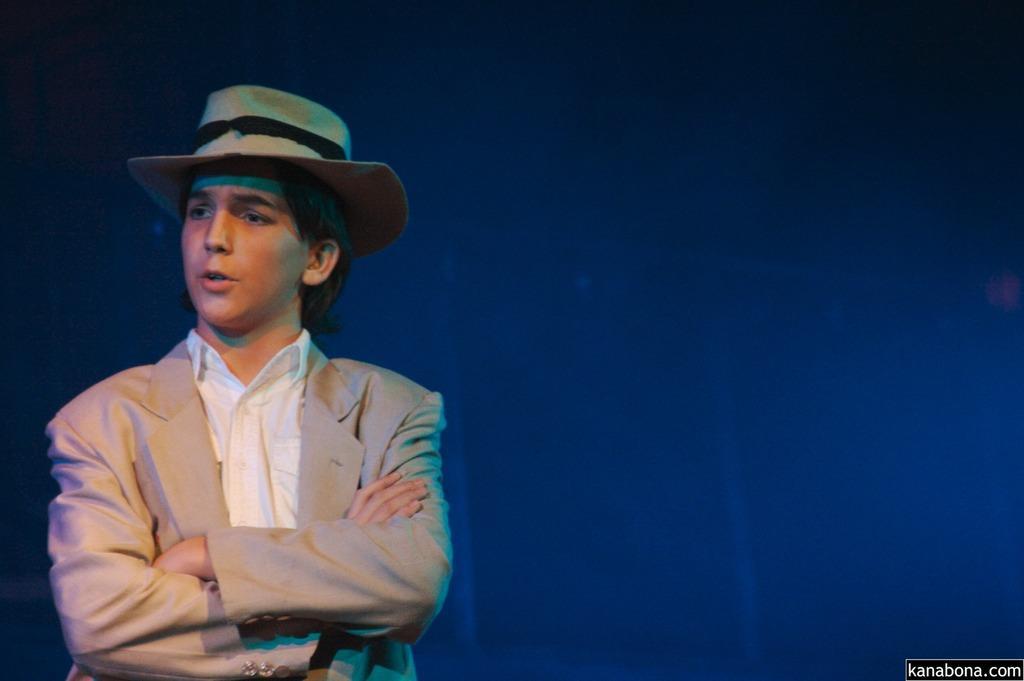Describe this image in one or two sentences. In this image there is one person standing on the left side of this image is wearing a cap and as we can see there is a blue color background. 